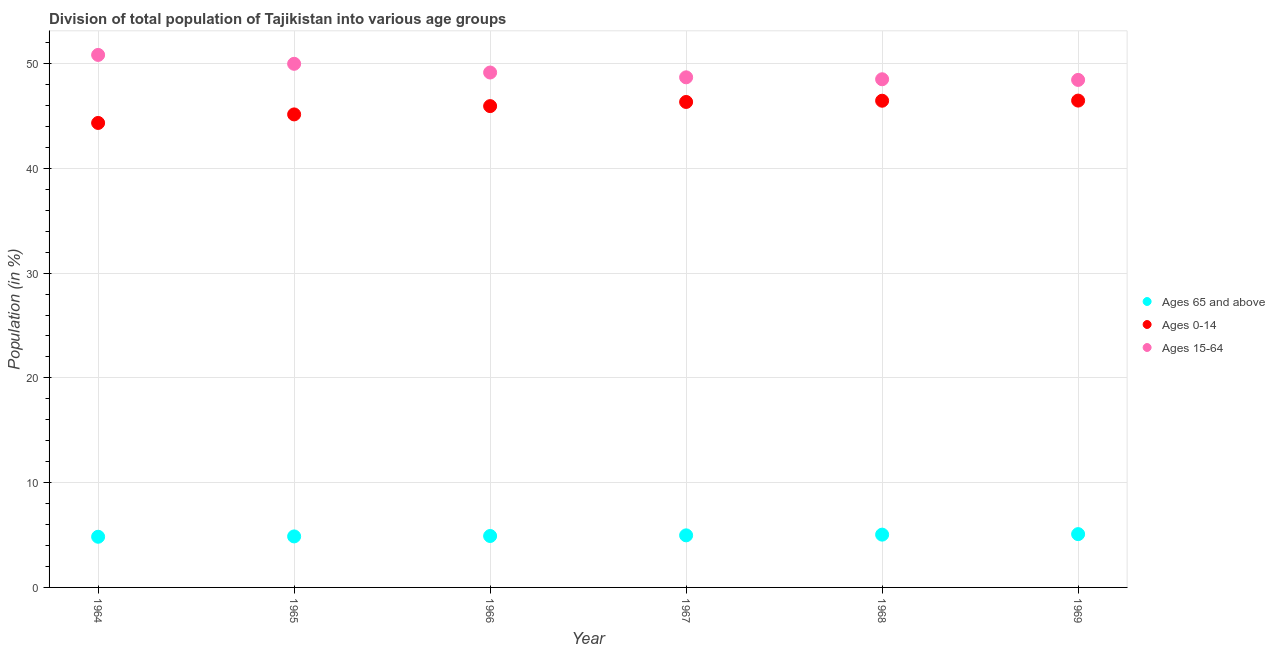How many different coloured dotlines are there?
Provide a succinct answer. 3. Is the number of dotlines equal to the number of legend labels?
Offer a terse response. Yes. What is the percentage of population within the age-group 0-14 in 1967?
Make the answer very short. 46.34. Across all years, what is the maximum percentage of population within the age-group 0-14?
Your answer should be compact. 46.47. Across all years, what is the minimum percentage of population within the age-group of 65 and above?
Provide a short and direct response. 4.84. In which year was the percentage of population within the age-group 15-64 maximum?
Make the answer very short. 1964. In which year was the percentage of population within the age-group of 65 and above minimum?
Provide a succinct answer. 1964. What is the total percentage of population within the age-group 0-14 in the graph?
Ensure brevity in your answer.  274.69. What is the difference between the percentage of population within the age-group 15-64 in 1964 and that in 1967?
Make the answer very short. 2.14. What is the difference between the percentage of population within the age-group 0-14 in 1968 and the percentage of population within the age-group of 65 and above in 1967?
Your answer should be compact. 41.48. What is the average percentage of population within the age-group 15-64 per year?
Your answer should be very brief. 49.27. In the year 1969, what is the difference between the percentage of population within the age-group 15-64 and percentage of population within the age-group of 65 and above?
Make the answer very short. 43.36. In how many years, is the percentage of population within the age-group 0-14 greater than 30 %?
Keep it short and to the point. 6. What is the ratio of the percentage of population within the age-group of 65 and above in 1965 to that in 1966?
Your response must be concise. 0.99. What is the difference between the highest and the second highest percentage of population within the age-group 15-64?
Your answer should be very brief. 0.85. What is the difference between the highest and the lowest percentage of population within the age-group 0-14?
Give a very brief answer. 2.13. In how many years, is the percentage of population within the age-group of 65 and above greater than the average percentage of population within the age-group of 65 and above taken over all years?
Your response must be concise. 3. Is the sum of the percentage of population within the age-group 15-64 in 1964 and 1969 greater than the maximum percentage of population within the age-group 0-14 across all years?
Offer a terse response. Yes. Is it the case that in every year, the sum of the percentage of population within the age-group of 65 and above and percentage of population within the age-group 0-14 is greater than the percentage of population within the age-group 15-64?
Your answer should be compact. No. Is the percentage of population within the age-group 15-64 strictly greater than the percentage of population within the age-group 0-14 over the years?
Your response must be concise. Yes. Is the percentage of population within the age-group 15-64 strictly less than the percentage of population within the age-group 0-14 over the years?
Give a very brief answer. No. How many years are there in the graph?
Provide a short and direct response. 6. What is the difference between two consecutive major ticks on the Y-axis?
Provide a short and direct response. 10. Are the values on the major ticks of Y-axis written in scientific E-notation?
Your response must be concise. No. Does the graph contain grids?
Offer a terse response. Yes. How many legend labels are there?
Make the answer very short. 3. How are the legend labels stacked?
Keep it short and to the point. Vertical. What is the title of the graph?
Keep it short and to the point. Division of total population of Tajikistan into various age groups
. Does "Domestic" appear as one of the legend labels in the graph?
Give a very brief answer. No. What is the label or title of the X-axis?
Your answer should be very brief. Year. What is the label or title of the Y-axis?
Provide a short and direct response. Population (in %). What is the Population (in %) in Ages 65 and above in 1964?
Provide a succinct answer. 4.84. What is the Population (in %) of Ages 0-14 in 1964?
Offer a very short reply. 44.33. What is the Population (in %) of Ages 15-64 in 1964?
Ensure brevity in your answer.  50.83. What is the Population (in %) of Ages 65 and above in 1965?
Your response must be concise. 4.87. What is the Population (in %) of Ages 0-14 in 1965?
Give a very brief answer. 45.15. What is the Population (in %) in Ages 15-64 in 1965?
Offer a terse response. 49.98. What is the Population (in %) in Ages 65 and above in 1966?
Your answer should be compact. 4.91. What is the Population (in %) of Ages 0-14 in 1966?
Provide a succinct answer. 45.94. What is the Population (in %) in Ages 15-64 in 1966?
Your answer should be compact. 49.15. What is the Population (in %) in Ages 65 and above in 1967?
Your answer should be very brief. 4.97. What is the Population (in %) in Ages 0-14 in 1967?
Offer a very short reply. 46.34. What is the Population (in %) of Ages 15-64 in 1967?
Offer a very short reply. 48.69. What is the Population (in %) in Ages 65 and above in 1968?
Provide a succinct answer. 5.04. What is the Population (in %) of Ages 0-14 in 1968?
Ensure brevity in your answer.  46.46. What is the Population (in %) of Ages 15-64 in 1968?
Your response must be concise. 48.51. What is the Population (in %) of Ages 65 and above in 1969?
Keep it short and to the point. 5.09. What is the Population (in %) of Ages 0-14 in 1969?
Offer a very short reply. 46.47. What is the Population (in %) in Ages 15-64 in 1969?
Your answer should be very brief. 48.44. Across all years, what is the maximum Population (in %) of Ages 65 and above?
Offer a very short reply. 5.09. Across all years, what is the maximum Population (in %) in Ages 0-14?
Ensure brevity in your answer.  46.47. Across all years, what is the maximum Population (in %) in Ages 15-64?
Make the answer very short. 50.83. Across all years, what is the minimum Population (in %) of Ages 65 and above?
Your answer should be compact. 4.84. Across all years, what is the minimum Population (in %) in Ages 0-14?
Provide a short and direct response. 44.33. Across all years, what is the minimum Population (in %) in Ages 15-64?
Offer a terse response. 48.44. What is the total Population (in %) in Ages 65 and above in the graph?
Provide a succinct answer. 29.71. What is the total Population (in %) of Ages 0-14 in the graph?
Provide a short and direct response. 274.69. What is the total Population (in %) in Ages 15-64 in the graph?
Make the answer very short. 295.6. What is the difference between the Population (in %) in Ages 65 and above in 1964 and that in 1965?
Provide a short and direct response. -0.03. What is the difference between the Population (in %) of Ages 0-14 in 1964 and that in 1965?
Your response must be concise. -0.82. What is the difference between the Population (in %) of Ages 15-64 in 1964 and that in 1965?
Make the answer very short. 0.85. What is the difference between the Population (in %) in Ages 65 and above in 1964 and that in 1966?
Ensure brevity in your answer.  -0.07. What is the difference between the Population (in %) in Ages 0-14 in 1964 and that in 1966?
Provide a short and direct response. -1.61. What is the difference between the Population (in %) in Ages 15-64 in 1964 and that in 1966?
Your answer should be very brief. 1.68. What is the difference between the Population (in %) of Ages 65 and above in 1964 and that in 1967?
Your answer should be very brief. -0.13. What is the difference between the Population (in %) in Ages 0-14 in 1964 and that in 1967?
Offer a very short reply. -2. What is the difference between the Population (in %) in Ages 15-64 in 1964 and that in 1967?
Keep it short and to the point. 2.14. What is the difference between the Population (in %) in Ages 65 and above in 1964 and that in 1968?
Your answer should be compact. -0.2. What is the difference between the Population (in %) of Ages 0-14 in 1964 and that in 1968?
Your answer should be very brief. -2.12. What is the difference between the Population (in %) of Ages 15-64 in 1964 and that in 1968?
Ensure brevity in your answer.  2.32. What is the difference between the Population (in %) in Ages 65 and above in 1964 and that in 1969?
Provide a short and direct response. -0.25. What is the difference between the Population (in %) in Ages 0-14 in 1964 and that in 1969?
Your answer should be very brief. -2.13. What is the difference between the Population (in %) in Ages 15-64 in 1964 and that in 1969?
Give a very brief answer. 2.39. What is the difference between the Population (in %) in Ages 65 and above in 1965 and that in 1966?
Offer a terse response. -0.04. What is the difference between the Population (in %) in Ages 0-14 in 1965 and that in 1966?
Ensure brevity in your answer.  -0.79. What is the difference between the Population (in %) in Ages 15-64 in 1965 and that in 1966?
Ensure brevity in your answer.  0.83. What is the difference between the Population (in %) in Ages 65 and above in 1965 and that in 1967?
Your answer should be very brief. -0.1. What is the difference between the Population (in %) in Ages 0-14 in 1965 and that in 1967?
Provide a short and direct response. -1.19. What is the difference between the Population (in %) of Ages 15-64 in 1965 and that in 1967?
Provide a succinct answer. 1.29. What is the difference between the Population (in %) in Ages 65 and above in 1965 and that in 1968?
Provide a short and direct response. -0.17. What is the difference between the Population (in %) of Ages 0-14 in 1965 and that in 1968?
Your answer should be compact. -1.31. What is the difference between the Population (in %) in Ages 15-64 in 1965 and that in 1968?
Your response must be concise. 1.47. What is the difference between the Population (in %) of Ages 65 and above in 1965 and that in 1969?
Make the answer very short. -0.22. What is the difference between the Population (in %) of Ages 0-14 in 1965 and that in 1969?
Offer a terse response. -1.32. What is the difference between the Population (in %) in Ages 15-64 in 1965 and that in 1969?
Your answer should be compact. 1.54. What is the difference between the Population (in %) in Ages 65 and above in 1966 and that in 1967?
Offer a very short reply. -0.06. What is the difference between the Population (in %) of Ages 0-14 in 1966 and that in 1967?
Give a very brief answer. -0.4. What is the difference between the Population (in %) in Ages 15-64 in 1966 and that in 1967?
Your answer should be very brief. 0.46. What is the difference between the Population (in %) in Ages 65 and above in 1966 and that in 1968?
Keep it short and to the point. -0.13. What is the difference between the Population (in %) in Ages 0-14 in 1966 and that in 1968?
Offer a very short reply. -0.51. What is the difference between the Population (in %) in Ages 15-64 in 1966 and that in 1968?
Give a very brief answer. 0.64. What is the difference between the Population (in %) of Ages 65 and above in 1966 and that in 1969?
Your answer should be very brief. -0.18. What is the difference between the Population (in %) of Ages 0-14 in 1966 and that in 1969?
Offer a terse response. -0.53. What is the difference between the Population (in %) in Ages 15-64 in 1966 and that in 1969?
Offer a terse response. 0.71. What is the difference between the Population (in %) of Ages 65 and above in 1967 and that in 1968?
Your answer should be compact. -0.07. What is the difference between the Population (in %) in Ages 0-14 in 1967 and that in 1968?
Offer a very short reply. -0.12. What is the difference between the Population (in %) of Ages 15-64 in 1967 and that in 1968?
Offer a terse response. 0.19. What is the difference between the Population (in %) of Ages 65 and above in 1967 and that in 1969?
Offer a very short reply. -0.12. What is the difference between the Population (in %) of Ages 0-14 in 1967 and that in 1969?
Offer a terse response. -0.13. What is the difference between the Population (in %) of Ages 15-64 in 1967 and that in 1969?
Your answer should be compact. 0.25. What is the difference between the Population (in %) of Ages 65 and above in 1968 and that in 1969?
Your answer should be compact. -0.05. What is the difference between the Population (in %) in Ages 0-14 in 1968 and that in 1969?
Your response must be concise. -0.01. What is the difference between the Population (in %) in Ages 15-64 in 1968 and that in 1969?
Provide a short and direct response. 0.06. What is the difference between the Population (in %) of Ages 65 and above in 1964 and the Population (in %) of Ages 0-14 in 1965?
Your answer should be very brief. -40.31. What is the difference between the Population (in %) in Ages 65 and above in 1964 and the Population (in %) in Ages 15-64 in 1965?
Your answer should be compact. -45.14. What is the difference between the Population (in %) of Ages 0-14 in 1964 and the Population (in %) of Ages 15-64 in 1965?
Provide a short and direct response. -5.65. What is the difference between the Population (in %) in Ages 65 and above in 1964 and the Population (in %) in Ages 0-14 in 1966?
Your answer should be very brief. -41.11. What is the difference between the Population (in %) in Ages 65 and above in 1964 and the Population (in %) in Ages 15-64 in 1966?
Provide a short and direct response. -44.31. What is the difference between the Population (in %) of Ages 0-14 in 1964 and the Population (in %) of Ages 15-64 in 1966?
Your answer should be very brief. -4.81. What is the difference between the Population (in %) of Ages 65 and above in 1964 and the Population (in %) of Ages 0-14 in 1967?
Make the answer very short. -41.5. What is the difference between the Population (in %) in Ages 65 and above in 1964 and the Population (in %) in Ages 15-64 in 1967?
Your answer should be very brief. -43.85. What is the difference between the Population (in %) in Ages 0-14 in 1964 and the Population (in %) in Ages 15-64 in 1967?
Ensure brevity in your answer.  -4.36. What is the difference between the Population (in %) in Ages 65 and above in 1964 and the Population (in %) in Ages 0-14 in 1968?
Provide a succinct answer. -41.62. What is the difference between the Population (in %) in Ages 65 and above in 1964 and the Population (in %) in Ages 15-64 in 1968?
Make the answer very short. -43.67. What is the difference between the Population (in %) of Ages 0-14 in 1964 and the Population (in %) of Ages 15-64 in 1968?
Provide a succinct answer. -4.17. What is the difference between the Population (in %) of Ages 65 and above in 1964 and the Population (in %) of Ages 0-14 in 1969?
Your answer should be compact. -41.63. What is the difference between the Population (in %) in Ages 65 and above in 1964 and the Population (in %) in Ages 15-64 in 1969?
Provide a succinct answer. -43.61. What is the difference between the Population (in %) of Ages 0-14 in 1964 and the Population (in %) of Ages 15-64 in 1969?
Your answer should be compact. -4.11. What is the difference between the Population (in %) in Ages 65 and above in 1965 and the Population (in %) in Ages 0-14 in 1966?
Give a very brief answer. -41.07. What is the difference between the Population (in %) of Ages 65 and above in 1965 and the Population (in %) of Ages 15-64 in 1966?
Offer a terse response. -44.28. What is the difference between the Population (in %) of Ages 0-14 in 1965 and the Population (in %) of Ages 15-64 in 1966?
Keep it short and to the point. -4. What is the difference between the Population (in %) in Ages 65 and above in 1965 and the Population (in %) in Ages 0-14 in 1967?
Your answer should be very brief. -41.47. What is the difference between the Population (in %) of Ages 65 and above in 1965 and the Population (in %) of Ages 15-64 in 1967?
Your answer should be very brief. -43.82. What is the difference between the Population (in %) of Ages 0-14 in 1965 and the Population (in %) of Ages 15-64 in 1967?
Your response must be concise. -3.54. What is the difference between the Population (in %) of Ages 65 and above in 1965 and the Population (in %) of Ages 0-14 in 1968?
Give a very brief answer. -41.59. What is the difference between the Population (in %) in Ages 65 and above in 1965 and the Population (in %) in Ages 15-64 in 1968?
Offer a very short reply. -43.64. What is the difference between the Population (in %) in Ages 0-14 in 1965 and the Population (in %) in Ages 15-64 in 1968?
Provide a short and direct response. -3.35. What is the difference between the Population (in %) in Ages 65 and above in 1965 and the Population (in %) in Ages 0-14 in 1969?
Your answer should be compact. -41.6. What is the difference between the Population (in %) of Ages 65 and above in 1965 and the Population (in %) of Ages 15-64 in 1969?
Your answer should be compact. -43.57. What is the difference between the Population (in %) in Ages 0-14 in 1965 and the Population (in %) in Ages 15-64 in 1969?
Give a very brief answer. -3.29. What is the difference between the Population (in %) in Ages 65 and above in 1966 and the Population (in %) in Ages 0-14 in 1967?
Provide a short and direct response. -41.43. What is the difference between the Population (in %) in Ages 65 and above in 1966 and the Population (in %) in Ages 15-64 in 1967?
Your answer should be compact. -43.78. What is the difference between the Population (in %) in Ages 0-14 in 1966 and the Population (in %) in Ages 15-64 in 1967?
Keep it short and to the point. -2.75. What is the difference between the Population (in %) in Ages 65 and above in 1966 and the Population (in %) in Ages 0-14 in 1968?
Offer a very short reply. -41.55. What is the difference between the Population (in %) of Ages 65 and above in 1966 and the Population (in %) of Ages 15-64 in 1968?
Give a very brief answer. -43.6. What is the difference between the Population (in %) in Ages 0-14 in 1966 and the Population (in %) in Ages 15-64 in 1968?
Keep it short and to the point. -2.56. What is the difference between the Population (in %) of Ages 65 and above in 1966 and the Population (in %) of Ages 0-14 in 1969?
Your answer should be very brief. -41.56. What is the difference between the Population (in %) of Ages 65 and above in 1966 and the Population (in %) of Ages 15-64 in 1969?
Ensure brevity in your answer.  -43.53. What is the difference between the Population (in %) of Ages 0-14 in 1966 and the Population (in %) of Ages 15-64 in 1969?
Offer a terse response. -2.5. What is the difference between the Population (in %) of Ages 65 and above in 1967 and the Population (in %) of Ages 0-14 in 1968?
Make the answer very short. -41.48. What is the difference between the Population (in %) of Ages 65 and above in 1967 and the Population (in %) of Ages 15-64 in 1968?
Offer a terse response. -43.53. What is the difference between the Population (in %) in Ages 0-14 in 1967 and the Population (in %) in Ages 15-64 in 1968?
Your response must be concise. -2.17. What is the difference between the Population (in %) in Ages 65 and above in 1967 and the Population (in %) in Ages 0-14 in 1969?
Provide a short and direct response. -41.5. What is the difference between the Population (in %) of Ages 65 and above in 1967 and the Population (in %) of Ages 15-64 in 1969?
Ensure brevity in your answer.  -43.47. What is the difference between the Population (in %) in Ages 0-14 in 1967 and the Population (in %) in Ages 15-64 in 1969?
Make the answer very short. -2.1. What is the difference between the Population (in %) in Ages 65 and above in 1968 and the Population (in %) in Ages 0-14 in 1969?
Ensure brevity in your answer.  -41.43. What is the difference between the Population (in %) in Ages 65 and above in 1968 and the Population (in %) in Ages 15-64 in 1969?
Your answer should be very brief. -43.4. What is the difference between the Population (in %) in Ages 0-14 in 1968 and the Population (in %) in Ages 15-64 in 1969?
Offer a terse response. -1.99. What is the average Population (in %) in Ages 65 and above per year?
Offer a terse response. 4.95. What is the average Population (in %) of Ages 0-14 per year?
Offer a terse response. 45.78. What is the average Population (in %) of Ages 15-64 per year?
Your answer should be compact. 49.27. In the year 1964, what is the difference between the Population (in %) of Ages 65 and above and Population (in %) of Ages 0-14?
Ensure brevity in your answer.  -39.5. In the year 1964, what is the difference between the Population (in %) of Ages 65 and above and Population (in %) of Ages 15-64?
Your response must be concise. -45.99. In the year 1964, what is the difference between the Population (in %) in Ages 0-14 and Population (in %) in Ages 15-64?
Provide a succinct answer. -6.49. In the year 1965, what is the difference between the Population (in %) of Ages 65 and above and Population (in %) of Ages 0-14?
Offer a very short reply. -40.28. In the year 1965, what is the difference between the Population (in %) of Ages 65 and above and Population (in %) of Ages 15-64?
Ensure brevity in your answer.  -45.11. In the year 1965, what is the difference between the Population (in %) in Ages 0-14 and Population (in %) in Ages 15-64?
Keep it short and to the point. -4.83. In the year 1966, what is the difference between the Population (in %) in Ages 65 and above and Population (in %) in Ages 0-14?
Provide a succinct answer. -41.03. In the year 1966, what is the difference between the Population (in %) in Ages 65 and above and Population (in %) in Ages 15-64?
Ensure brevity in your answer.  -44.24. In the year 1966, what is the difference between the Population (in %) of Ages 0-14 and Population (in %) of Ages 15-64?
Your answer should be compact. -3.21. In the year 1967, what is the difference between the Population (in %) in Ages 65 and above and Population (in %) in Ages 0-14?
Your answer should be compact. -41.37. In the year 1967, what is the difference between the Population (in %) in Ages 65 and above and Population (in %) in Ages 15-64?
Your response must be concise. -43.72. In the year 1967, what is the difference between the Population (in %) of Ages 0-14 and Population (in %) of Ages 15-64?
Provide a short and direct response. -2.35. In the year 1968, what is the difference between the Population (in %) of Ages 65 and above and Population (in %) of Ages 0-14?
Ensure brevity in your answer.  -41.42. In the year 1968, what is the difference between the Population (in %) in Ages 65 and above and Population (in %) in Ages 15-64?
Offer a terse response. -43.47. In the year 1968, what is the difference between the Population (in %) in Ages 0-14 and Population (in %) in Ages 15-64?
Ensure brevity in your answer.  -2.05. In the year 1969, what is the difference between the Population (in %) in Ages 65 and above and Population (in %) in Ages 0-14?
Your answer should be compact. -41.38. In the year 1969, what is the difference between the Population (in %) in Ages 65 and above and Population (in %) in Ages 15-64?
Make the answer very short. -43.36. In the year 1969, what is the difference between the Population (in %) of Ages 0-14 and Population (in %) of Ages 15-64?
Give a very brief answer. -1.97. What is the ratio of the Population (in %) of Ages 65 and above in 1964 to that in 1965?
Provide a short and direct response. 0.99. What is the ratio of the Population (in %) in Ages 0-14 in 1964 to that in 1965?
Provide a succinct answer. 0.98. What is the ratio of the Population (in %) of Ages 15-64 in 1964 to that in 1965?
Give a very brief answer. 1.02. What is the ratio of the Population (in %) in Ages 65 and above in 1964 to that in 1966?
Your answer should be compact. 0.99. What is the ratio of the Population (in %) in Ages 0-14 in 1964 to that in 1966?
Ensure brevity in your answer.  0.96. What is the ratio of the Population (in %) of Ages 15-64 in 1964 to that in 1966?
Make the answer very short. 1.03. What is the ratio of the Population (in %) of Ages 65 and above in 1964 to that in 1967?
Make the answer very short. 0.97. What is the ratio of the Population (in %) of Ages 0-14 in 1964 to that in 1967?
Keep it short and to the point. 0.96. What is the ratio of the Population (in %) of Ages 15-64 in 1964 to that in 1967?
Your response must be concise. 1.04. What is the ratio of the Population (in %) in Ages 65 and above in 1964 to that in 1968?
Provide a succinct answer. 0.96. What is the ratio of the Population (in %) of Ages 0-14 in 1964 to that in 1968?
Ensure brevity in your answer.  0.95. What is the ratio of the Population (in %) of Ages 15-64 in 1964 to that in 1968?
Make the answer very short. 1.05. What is the ratio of the Population (in %) in Ages 65 and above in 1964 to that in 1969?
Give a very brief answer. 0.95. What is the ratio of the Population (in %) of Ages 0-14 in 1964 to that in 1969?
Your response must be concise. 0.95. What is the ratio of the Population (in %) of Ages 15-64 in 1964 to that in 1969?
Provide a short and direct response. 1.05. What is the ratio of the Population (in %) in Ages 65 and above in 1965 to that in 1966?
Offer a terse response. 0.99. What is the ratio of the Population (in %) of Ages 0-14 in 1965 to that in 1966?
Provide a succinct answer. 0.98. What is the ratio of the Population (in %) of Ages 15-64 in 1965 to that in 1966?
Your answer should be compact. 1.02. What is the ratio of the Population (in %) of Ages 65 and above in 1965 to that in 1967?
Make the answer very short. 0.98. What is the ratio of the Population (in %) of Ages 0-14 in 1965 to that in 1967?
Provide a short and direct response. 0.97. What is the ratio of the Population (in %) of Ages 15-64 in 1965 to that in 1967?
Give a very brief answer. 1.03. What is the ratio of the Population (in %) of Ages 65 and above in 1965 to that in 1968?
Give a very brief answer. 0.97. What is the ratio of the Population (in %) of Ages 0-14 in 1965 to that in 1968?
Provide a succinct answer. 0.97. What is the ratio of the Population (in %) of Ages 15-64 in 1965 to that in 1968?
Provide a short and direct response. 1.03. What is the ratio of the Population (in %) in Ages 65 and above in 1965 to that in 1969?
Your answer should be compact. 0.96. What is the ratio of the Population (in %) of Ages 0-14 in 1965 to that in 1969?
Ensure brevity in your answer.  0.97. What is the ratio of the Population (in %) of Ages 15-64 in 1965 to that in 1969?
Your answer should be compact. 1.03. What is the ratio of the Population (in %) in Ages 65 and above in 1966 to that in 1967?
Provide a short and direct response. 0.99. What is the ratio of the Population (in %) in Ages 15-64 in 1966 to that in 1967?
Your response must be concise. 1.01. What is the ratio of the Population (in %) of Ages 65 and above in 1966 to that in 1968?
Your answer should be very brief. 0.97. What is the ratio of the Population (in %) of Ages 0-14 in 1966 to that in 1968?
Your answer should be compact. 0.99. What is the ratio of the Population (in %) of Ages 15-64 in 1966 to that in 1968?
Offer a very short reply. 1.01. What is the ratio of the Population (in %) in Ages 65 and above in 1966 to that in 1969?
Offer a very short reply. 0.96. What is the ratio of the Population (in %) of Ages 0-14 in 1966 to that in 1969?
Make the answer very short. 0.99. What is the ratio of the Population (in %) of Ages 15-64 in 1966 to that in 1969?
Your answer should be very brief. 1.01. What is the ratio of the Population (in %) of Ages 65 and above in 1967 to that in 1968?
Offer a very short reply. 0.99. What is the ratio of the Population (in %) of Ages 0-14 in 1967 to that in 1968?
Keep it short and to the point. 1. What is the ratio of the Population (in %) of Ages 65 and above in 1968 to that in 1969?
Your response must be concise. 0.99. What is the ratio of the Population (in %) of Ages 0-14 in 1968 to that in 1969?
Offer a very short reply. 1. What is the ratio of the Population (in %) in Ages 15-64 in 1968 to that in 1969?
Ensure brevity in your answer.  1. What is the difference between the highest and the second highest Population (in %) in Ages 65 and above?
Ensure brevity in your answer.  0.05. What is the difference between the highest and the second highest Population (in %) of Ages 0-14?
Make the answer very short. 0.01. What is the difference between the highest and the second highest Population (in %) in Ages 15-64?
Ensure brevity in your answer.  0.85. What is the difference between the highest and the lowest Population (in %) in Ages 65 and above?
Offer a terse response. 0.25. What is the difference between the highest and the lowest Population (in %) in Ages 0-14?
Make the answer very short. 2.13. What is the difference between the highest and the lowest Population (in %) of Ages 15-64?
Ensure brevity in your answer.  2.39. 